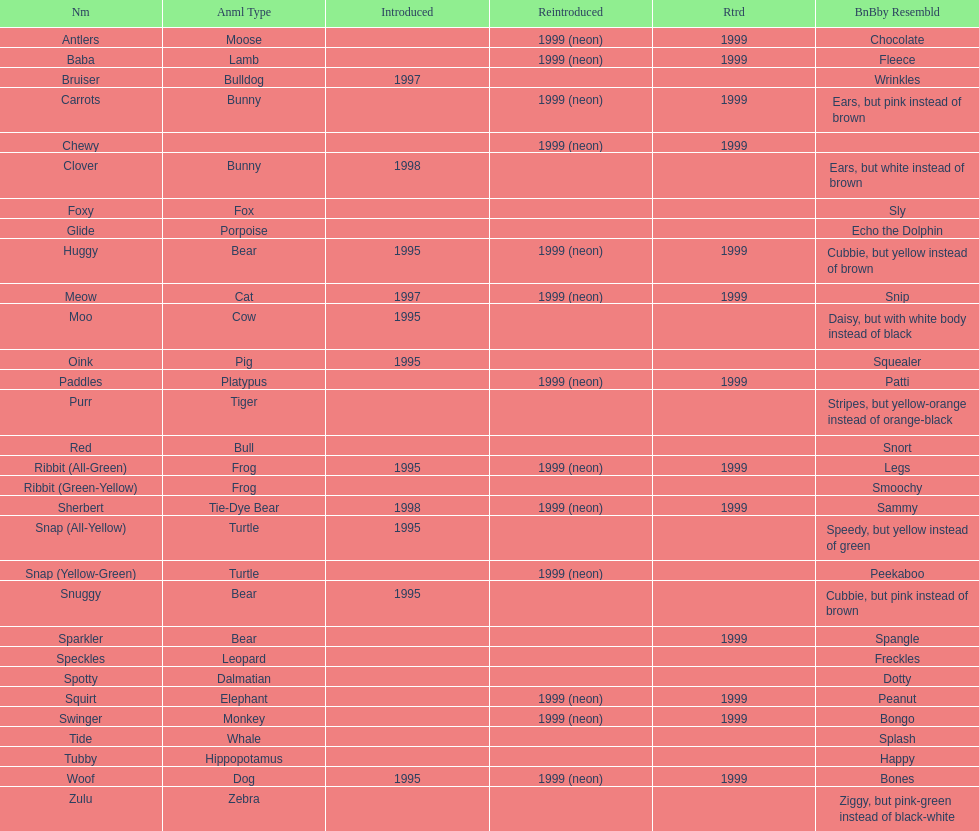What are all the different names of the pillow pals? Antlers, Baba, Bruiser, Carrots, Chewy, Clover, Foxy, Glide, Huggy, Meow, Moo, Oink, Paddles, Purr, Red, Ribbit (All-Green), Ribbit (Green-Yellow), Sherbert, Snap (All-Yellow), Snap (Yellow-Green), Snuggy, Sparkler, Speckles, Spotty, Squirt, Swinger, Tide, Tubby, Woof, Zulu. Which of these are a dalmatian? Spotty. 